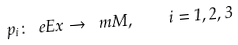<formula> <loc_0><loc_0><loc_500><loc_500>p _ { i } \colon \ e E x \to \ m M , \quad i = 1 , 2 , 3</formula> 